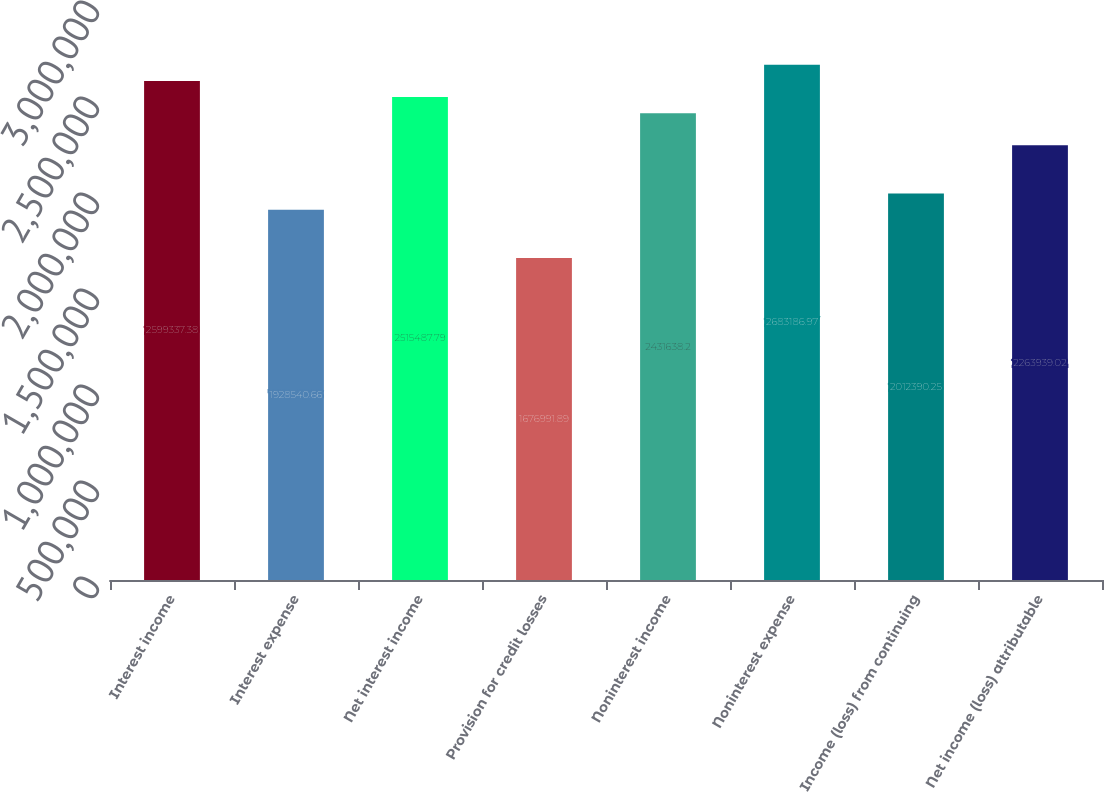Convert chart. <chart><loc_0><loc_0><loc_500><loc_500><bar_chart><fcel>Interest income<fcel>Interest expense<fcel>Net interest income<fcel>Provision for credit losses<fcel>Noninterest income<fcel>Noninterest expense<fcel>Income (loss) from continuing<fcel>Net income (loss) attributable<nl><fcel>2.59934e+06<fcel>1.92854e+06<fcel>2.51549e+06<fcel>1.67699e+06<fcel>2.43164e+06<fcel>2.68319e+06<fcel>2.01239e+06<fcel>2.26394e+06<nl></chart> 